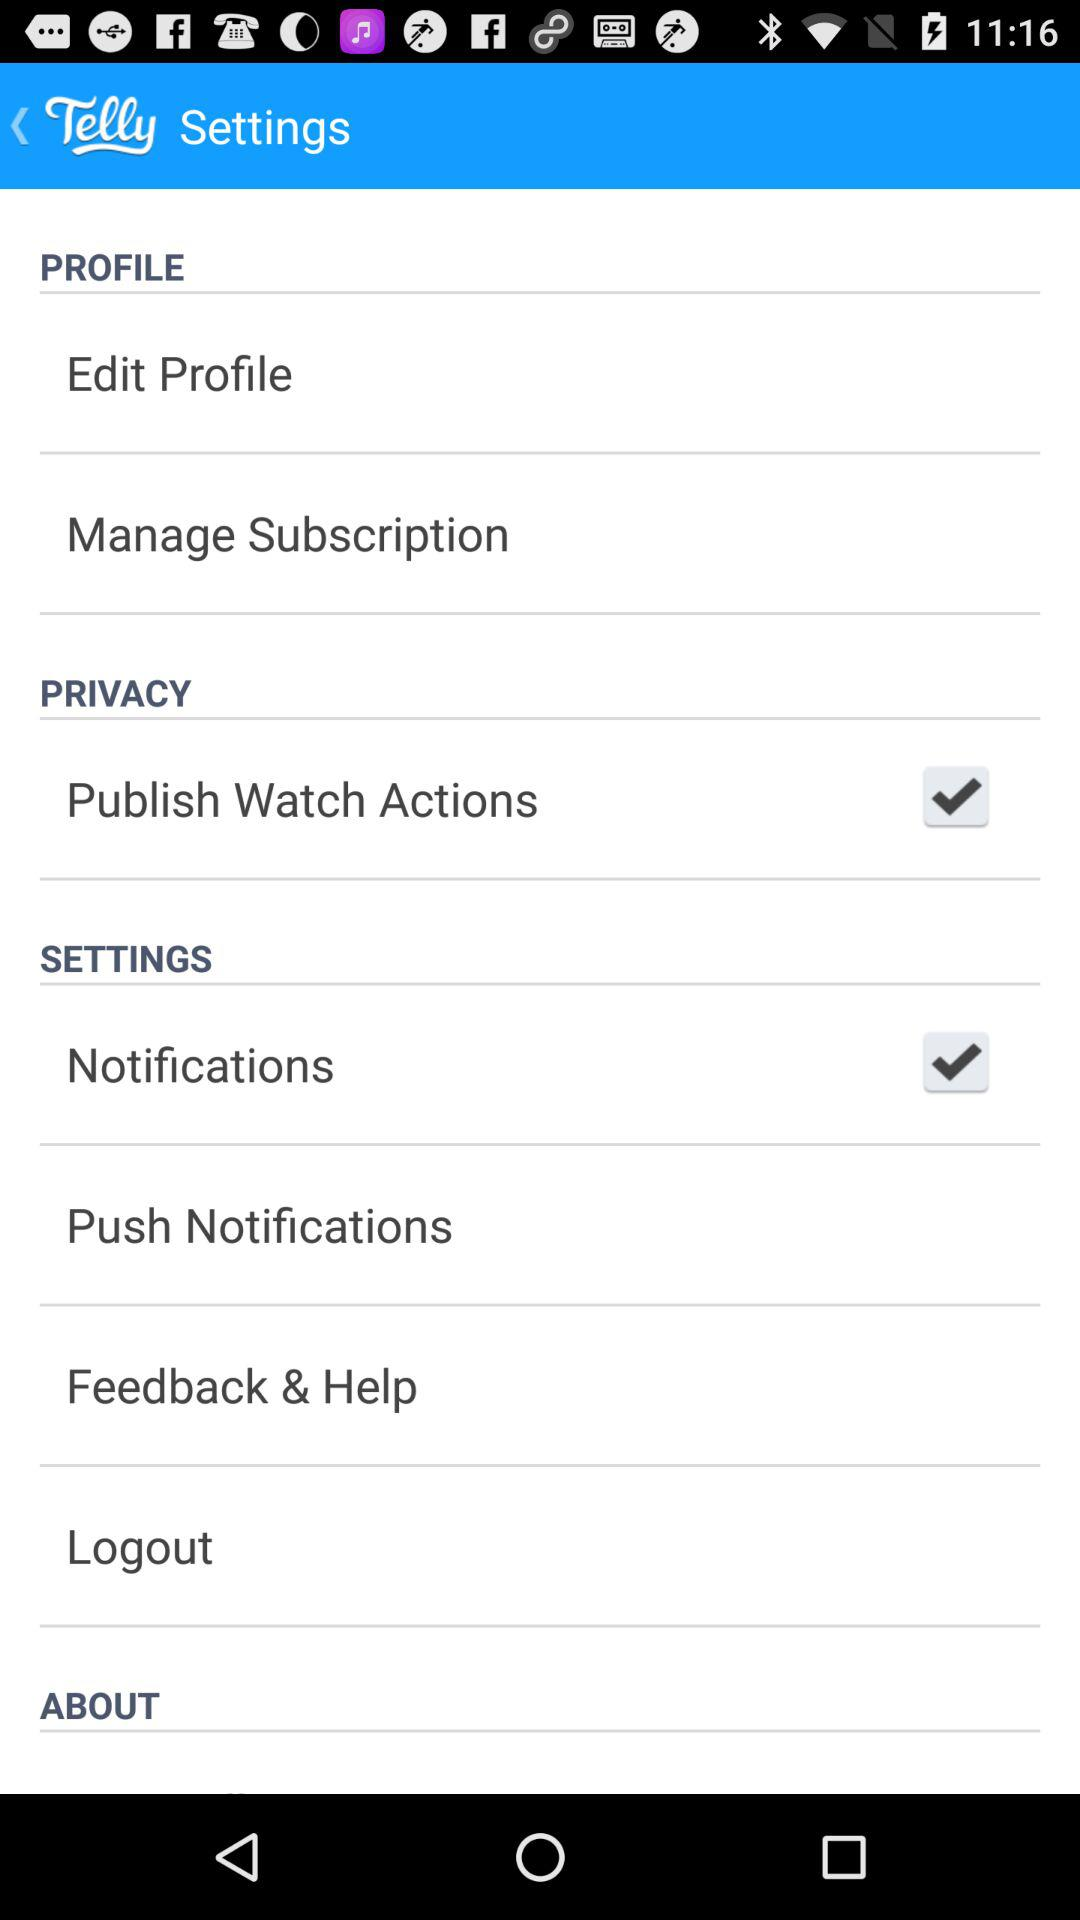What is the application name? The application name is "Telly". 